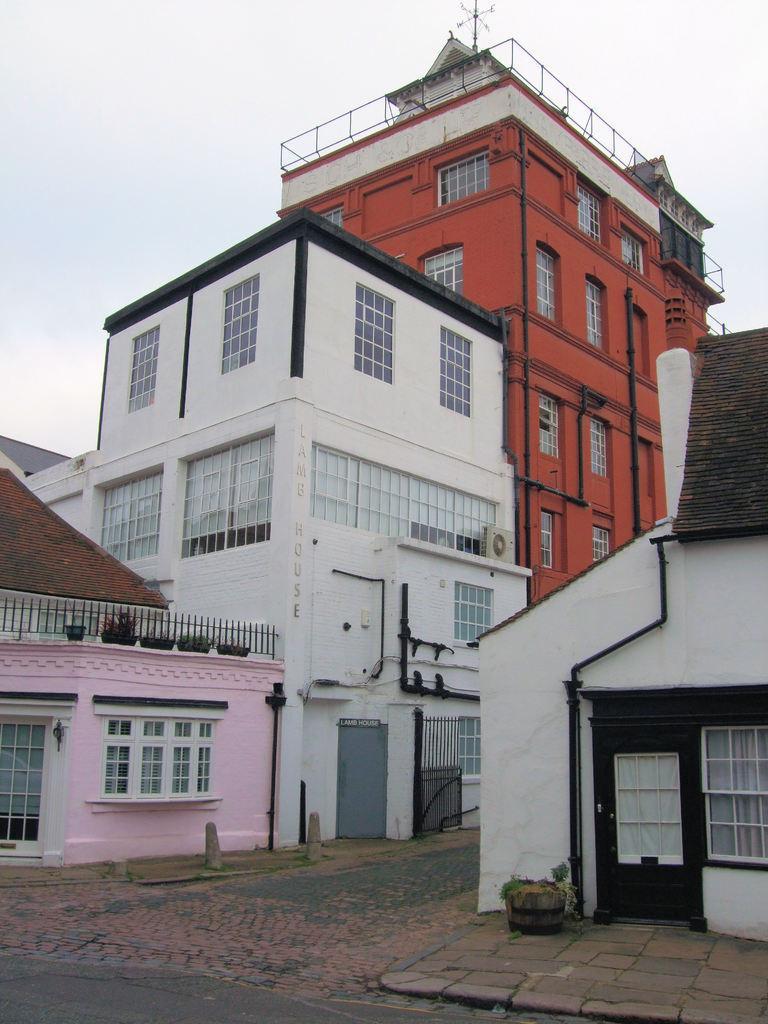Please provide a concise description of this image. In this picture we can see buildings. To these buildings there are windows. Here we can see plants. Sky is cloudy. These are pipes. 